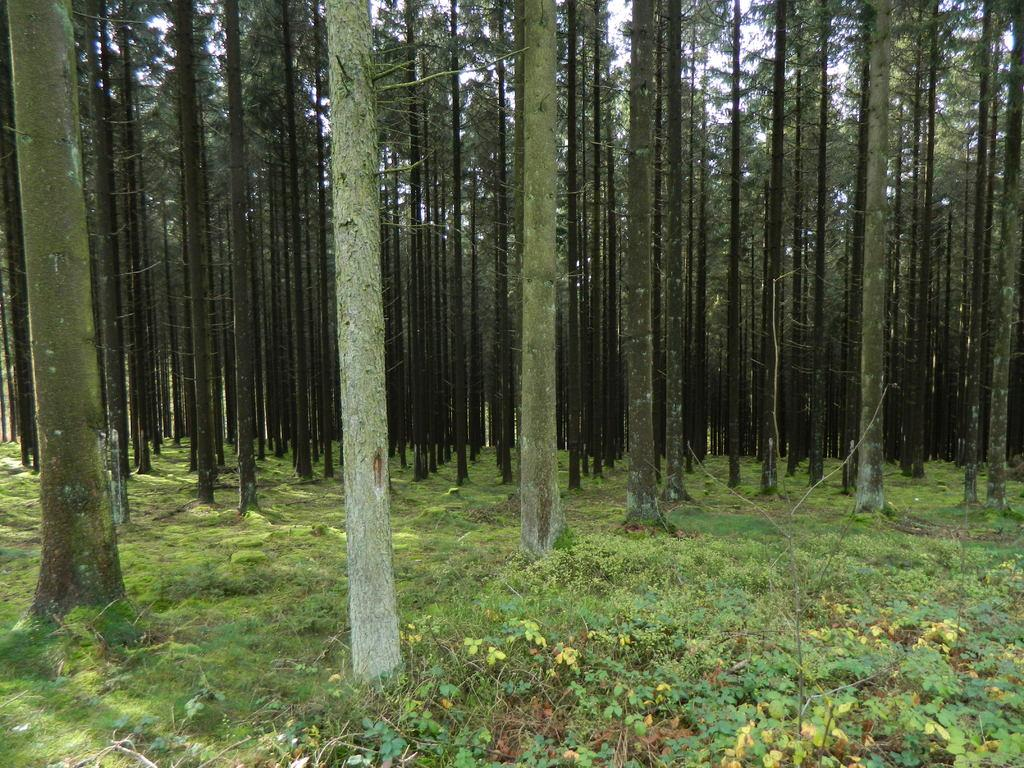What type of terrain is visible in the image? There is an open grass ground in the image. Are there any other natural elements present on the grass ground? Yes, there are multiple trees on the grass ground. What type of glass object can be seen on the grass ground in the image? There is no glass object present on the grass ground in the image. How low are the trees on the grass ground in the image? The height of the trees cannot be determined from the image alone, as only their presence is mentioned. 